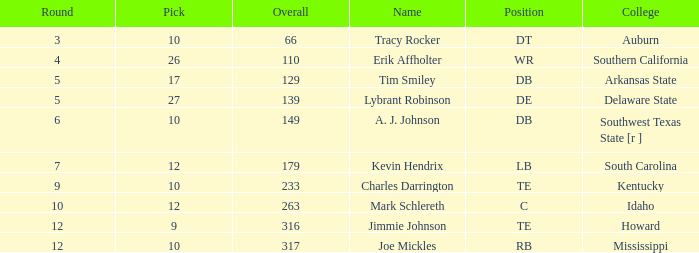What is the total of overall when the college is "arkansas state" and the pick is under 17? None. 